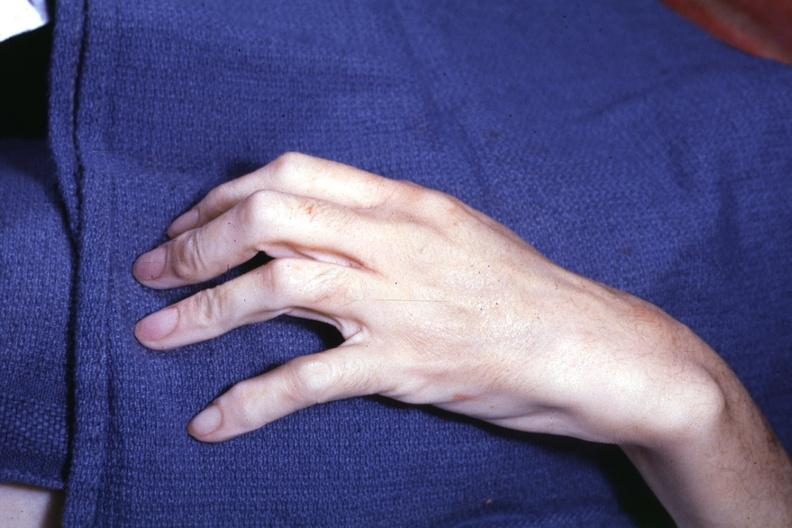re extremities present?
Answer the question using a single word or phrase. Yes 